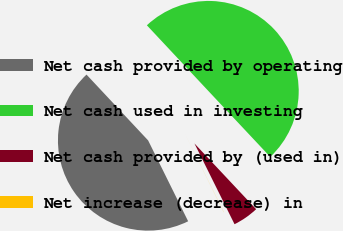<chart> <loc_0><loc_0><loc_500><loc_500><pie_chart><fcel>Net cash provided by operating<fcel>Net cash used in investing<fcel>Net cash provided by (used in)<fcel>Net increase (decrease) in<nl><fcel>45.34%<fcel>49.98%<fcel>4.66%<fcel>0.02%<nl></chart> 